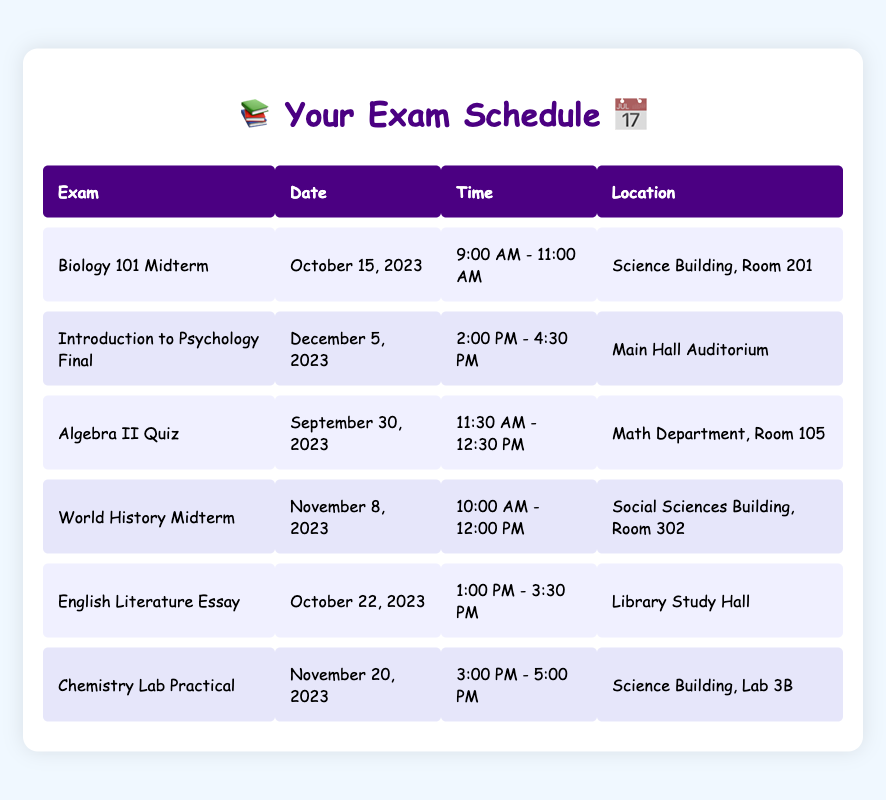What is the date for the Biology 101 Midterm? The table lists the exam dates, and under the "Exam" column, "Biology 101 Midterm" corresponds to the date in the "Date" column, which is October 15, 2023.
Answer: October 15, 2023 Where is the Introduction to Psychology Final held? The table provides the location details for each exam. For "Introduction to Psychology Final," the "Location" column shows it will be held in the "Main Hall Auditorium."
Answer: Main Hall Auditorium Which exam takes place on November 20, 2023? To find this out, look at the "Date" column. The only exam scheduled for that date is "Chemistry Lab Practical."
Answer: Chemistry Lab Practical What is the time for the English Literature Essay? The table indicates the "Time" for each exam. For "English Literature Essay," the time listed is "1:00 PM - 3:30 PM."
Answer: 1:00 PM - 3:30 PM Is the Algebra II Quiz scheduled before the Biology 101 Midterm? By looking at the dates in the "Date" column, the Algebra II Quiz is on September 30, 2023, while Biology 101 Midterm is on October 15, 2023. Since September 30 is before October 15, the statement is true.
Answer: Yes How many exams are scheduled in November 2023? To determine this, count the number of exams listed in the "Date" column that fall in November 2023. The exams are "World History Midterm" (November 8) and "Chemistry Lab Practical" (November 20), giving a total of 2 exams.
Answer: 2 What is the interval between the Algebra II Quiz and the Biology 101 Midterm? The Algebra II Quiz is on September 30, while the Biology 101 Midterm is on October 15. This means the interval is from September 30 to October 15, which is 15 days.
Answer: 15 days Which exam has the longest duration? The durations for each exam can be calculated as follows: Biology 101 Midterm (2 hours), Psychology Final (2.5 hours), Algebra II Quiz (1 hour), World History Midterm (2 hours), English Literature Essay (2.5 hours), Chemistry Lab Practical (2 hours). The longest durations are for Psychology Final and English Literature Essay, both lasting 2.5 hours.
Answer: Psychology Final and English Literature Essay What room is the World History Midterm held in? In the "Location" column, "World History Midterm" corresponds to the location "Social Sciences Building, Room 302."
Answer: Social Sciences Building, Room 302 